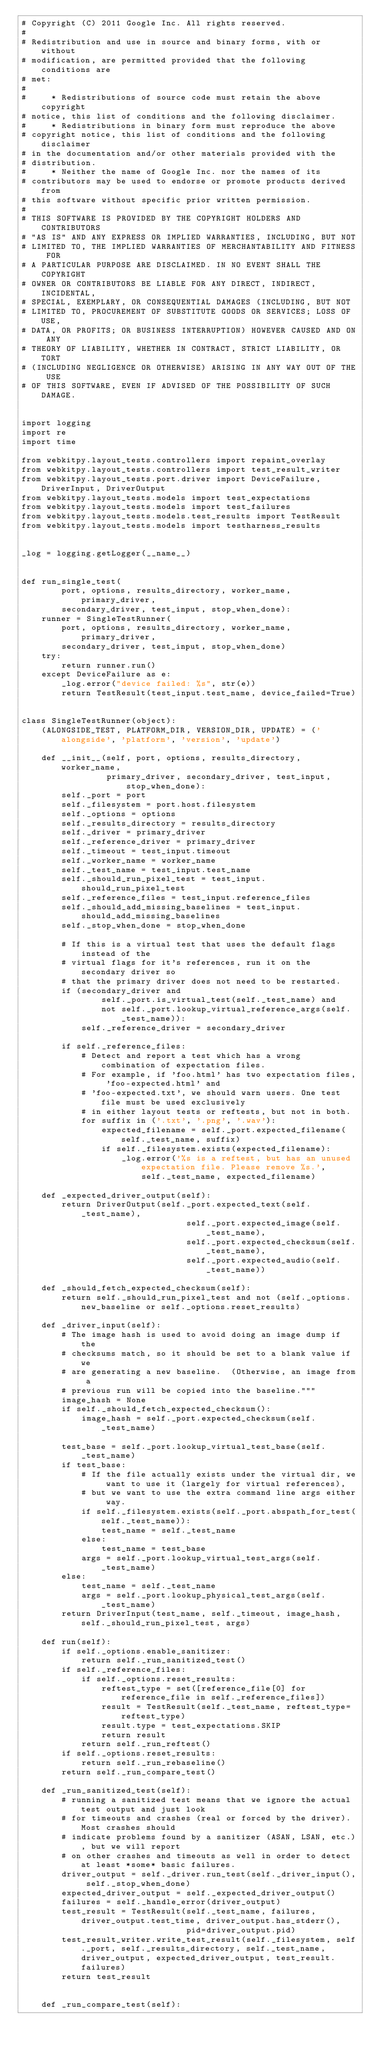<code> <loc_0><loc_0><loc_500><loc_500><_Python_># Copyright (C) 2011 Google Inc. All rights reserved.
#
# Redistribution and use in source and binary forms, with or without
# modification, are permitted provided that the following conditions are
# met:
#
#     * Redistributions of source code must retain the above copyright
# notice, this list of conditions and the following disclaimer.
#     * Redistributions in binary form must reproduce the above
# copyright notice, this list of conditions and the following disclaimer
# in the documentation and/or other materials provided with the
# distribution.
#     * Neither the name of Google Inc. nor the names of its
# contributors may be used to endorse or promote products derived from
# this software without specific prior written permission.
#
# THIS SOFTWARE IS PROVIDED BY THE COPYRIGHT HOLDERS AND CONTRIBUTORS
# "AS IS" AND ANY EXPRESS OR IMPLIED WARRANTIES, INCLUDING, BUT NOT
# LIMITED TO, THE IMPLIED WARRANTIES OF MERCHANTABILITY AND FITNESS FOR
# A PARTICULAR PURPOSE ARE DISCLAIMED. IN NO EVENT SHALL THE COPYRIGHT
# OWNER OR CONTRIBUTORS BE LIABLE FOR ANY DIRECT, INDIRECT, INCIDENTAL,
# SPECIAL, EXEMPLARY, OR CONSEQUENTIAL DAMAGES (INCLUDING, BUT NOT
# LIMITED TO, PROCUREMENT OF SUBSTITUTE GOODS OR SERVICES; LOSS OF USE,
# DATA, OR PROFITS; OR BUSINESS INTERRUPTION) HOWEVER CAUSED AND ON ANY
# THEORY OF LIABILITY, WHETHER IN CONTRACT, STRICT LIABILITY, OR TORT
# (INCLUDING NEGLIGENCE OR OTHERWISE) ARISING IN ANY WAY OUT OF THE USE
# OF THIS SOFTWARE, EVEN IF ADVISED OF THE POSSIBILITY OF SUCH DAMAGE.


import logging
import re
import time

from webkitpy.layout_tests.controllers import repaint_overlay
from webkitpy.layout_tests.controllers import test_result_writer
from webkitpy.layout_tests.port.driver import DeviceFailure, DriverInput, DriverOutput
from webkitpy.layout_tests.models import test_expectations
from webkitpy.layout_tests.models import test_failures
from webkitpy.layout_tests.models.test_results import TestResult
from webkitpy.layout_tests.models import testharness_results


_log = logging.getLogger(__name__)


def run_single_test(
        port, options, results_directory, worker_name, primary_driver,
        secondary_driver, test_input, stop_when_done):
    runner = SingleTestRunner(
        port, options, results_directory, worker_name, primary_driver,
        secondary_driver, test_input, stop_when_done)
    try:
        return runner.run()
    except DeviceFailure as e:
        _log.error("device failed: %s", str(e))
        return TestResult(test_input.test_name, device_failed=True)


class SingleTestRunner(object):
    (ALONGSIDE_TEST, PLATFORM_DIR, VERSION_DIR, UPDATE) = ('alongside', 'platform', 'version', 'update')

    def __init__(self, port, options, results_directory, worker_name,
                 primary_driver, secondary_driver, test_input, stop_when_done):
        self._port = port
        self._filesystem = port.host.filesystem
        self._options = options
        self._results_directory = results_directory
        self._driver = primary_driver
        self._reference_driver = primary_driver
        self._timeout = test_input.timeout
        self._worker_name = worker_name
        self._test_name = test_input.test_name
        self._should_run_pixel_test = test_input.should_run_pixel_test
        self._reference_files = test_input.reference_files
        self._should_add_missing_baselines = test_input.should_add_missing_baselines
        self._stop_when_done = stop_when_done

        # If this is a virtual test that uses the default flags instead of the
        # virtual flags for it's references, run it on the secondary driver so
        # that the primary driver does not need to be restarted.
        if (secondary_driver and
                self._port.is_virtual_test(self._test_name) and
                not self._port.lookup_virtual_reference_args(self._test_name)):
            self._reference_driver = secondary_driver

        if self._reference_files:
            # Detect and report a test which has a wrong combination of expectation files.
            # For example, if 'foo.html' has two expectation files, 'foo-expected.html' and
            # 'foo-expected.txt', we should warn users. One test file must be used exclusively
            # in either layout tests or reftests, but not in both.
            for suffix in ('.txt', '.png', '.wav'):
                expected_filename = self._port.expected_filename(self._test_name, suffix)
                if self._filesystem.exists(expected_filename):
                    _log.error('%s is a reftest, but has an unused expectation file. Please remove %s.',
                        self._test_name, expected_filename)

    def _expected_driver_output(self):
        return DriverOutput(self._port.expected_text(self._test_name),
                                 self._port.expected_image(self._test_name),
                                 self._port.expected_checksum(self._test_name),
                                 self._port.expected_audio(self._test_name))

    def _should_fetch_expected_checksum(self):
        return self._should_run_pixel_test and not (self._options.new_baseline or self._options.reset_results)

    def _driver_input(self):
        # The image hash is used to avoid doing an image dump if the
        # checksums match, so it should be set to a blank value if we
        # are generating a new baseline.  (Otherwise, an image from a
        # previous run will be copied into the baseline."""
        image_hash = None
        if self._should_fetch_expected_checksum():
            image_hash = self._port.expected_checksum(self._test_name)

        test_base = self._port.lookup_virtual_test_base(self._test_name)
        if test_base:
            # If the file actually exists under the virtual dir, we want to use it (largely for virtual references),
            # but we want to use the extra command line args either way.
            if self._filesystem.exists(self._port.abspath_for_test(self._test_name)):
                test_name = self._test_name
            else:
                test_name = test_base
            args = self._port.lookup_virtual_test_args(self._test_name)
        else:
            test_name = self._test_name
            args = self._port.lookup_physical_test_args(self._test_name)
        return DriverInput(test_name, self._timeout, image_hash, self._should_run_pixel_test, args)

    def run(self):
        if self._options.enable_sanitizer:
            return self._run_sanitized_test()
        if self._reference_files:
            if self._options.reset_results:
                reftest_type = set([reference_file[0] for reference_file in self._reference_files])
                result = TestResult(self._test_name, reftest_type=reftest_type)
                result.type = test_expectations.SKIP
                return result
            return self._run_reftest()
        if self._options.reset_results:
            return self._run_rebaseline()
        return self._run_compare_test()

    def _run_sanitized_test(self):
        # running a sanitized test means that we ignore the actual test output and just look
        # for timeouts and crashes (real or forced by the driver). Most crashes should
        # indicate problems found by a sanitizer (ASAN, LSAN, etc.), but we will report
        # on other crashes and timeouts as well in order to detect at least *some* basic failures.
        driver_output = self._driver.run_test(self._driver_input(), self._stop_when_done)
        expected_driver_output = self._expected_driver_output()
        failures = self._handle_error(driver_output)
        test_result = TestResult(self._test_name, failures, driver_output.test_time, driver_output.has_stderr(),
                                 pid=driver_output.pid)
        test_result_writer.write_test_result(self._filesystem, self._port, self._results_directory, self._test_name, driver_output, expected_driver_output, test_result.failures)
        return test_result


    def _run_compare_test(self):</code> 